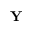<formula> <loc_0><loc_0><loc_500><loc_500>Y</formula> 